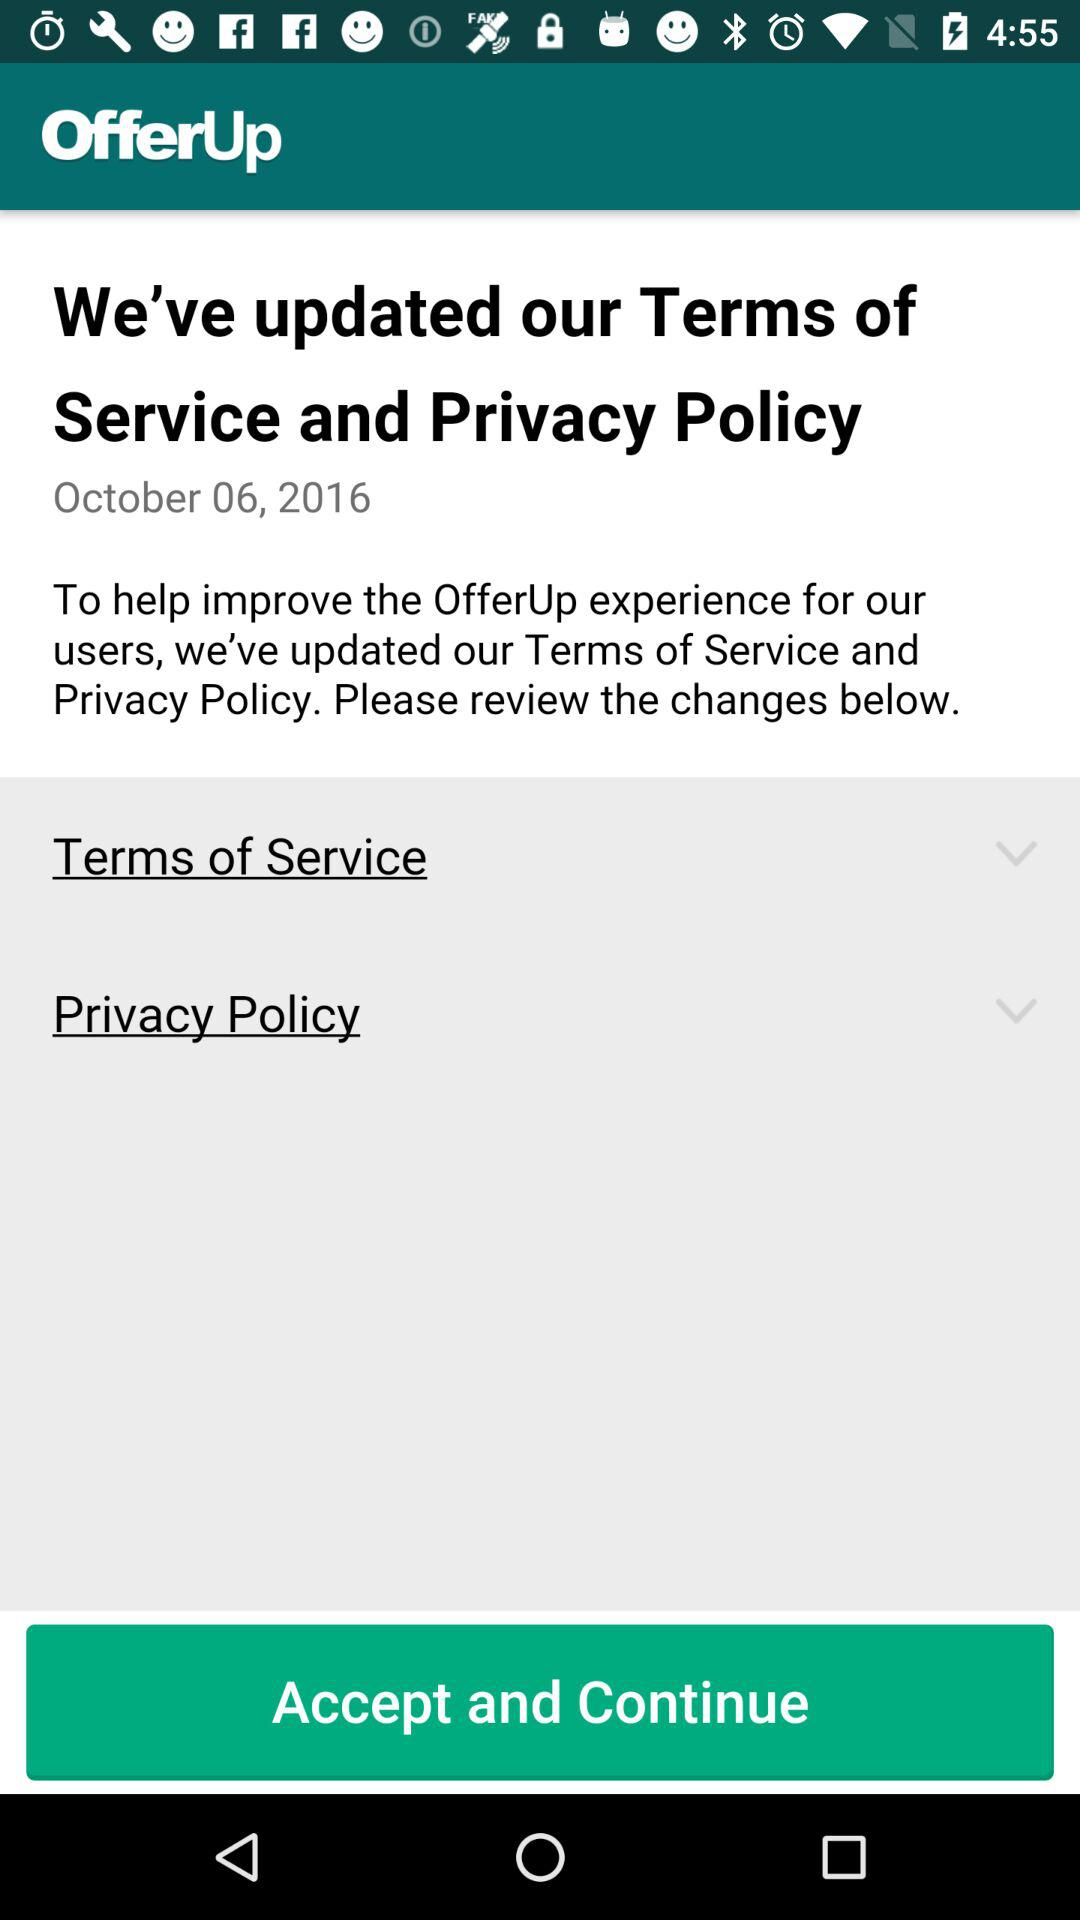What is the date? The date is October 06, 2016. 